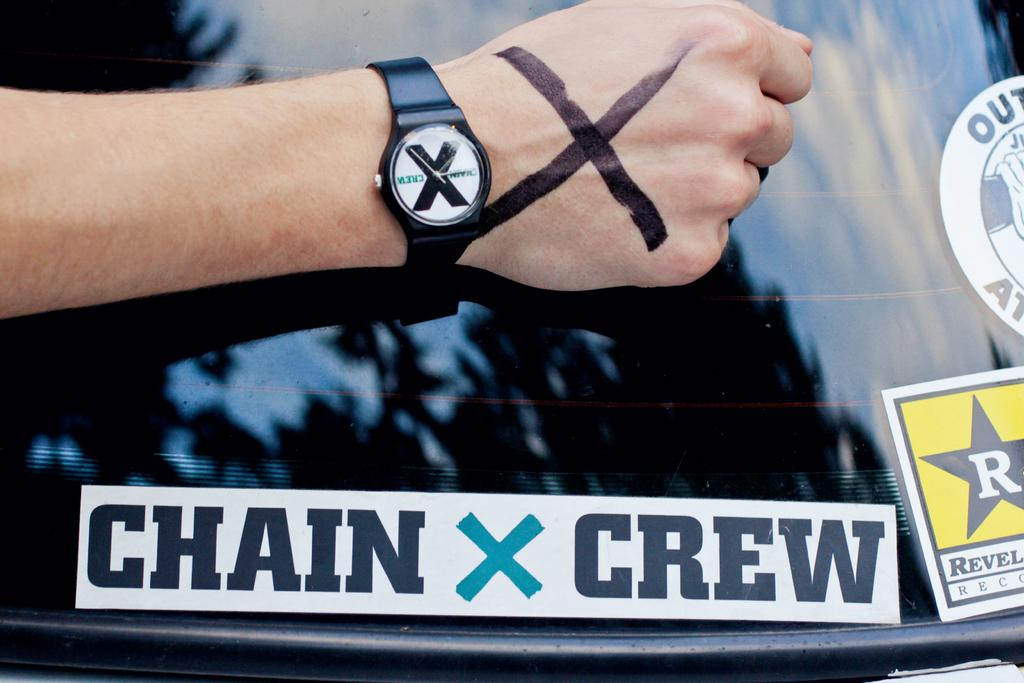<image>
Give a short and clear explanation of the subsequent image. A person holding their arm above a bumper sticker that says "Chain X Crew" wears a watch with an "X" on its face has and X drawn on their hand. 